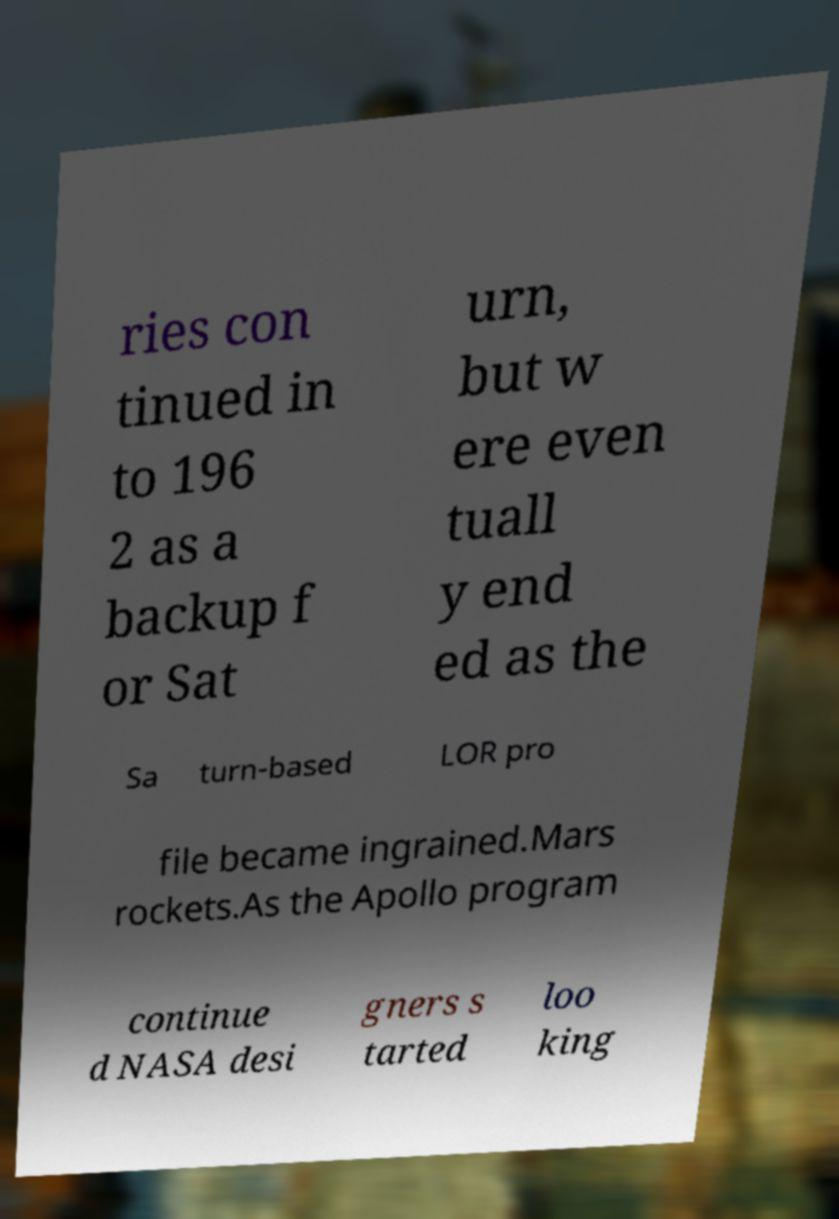I need the written content from this picture converted into text. Can you do that? ries con tinued in to 196 2 as a backup f or Sat urn, but w ere even tuall y end ed as the Sa turn-based LOR pro file became ingrained.Mars rockets.As the Apollo program continue d NASA desi gners s tarted loo king 